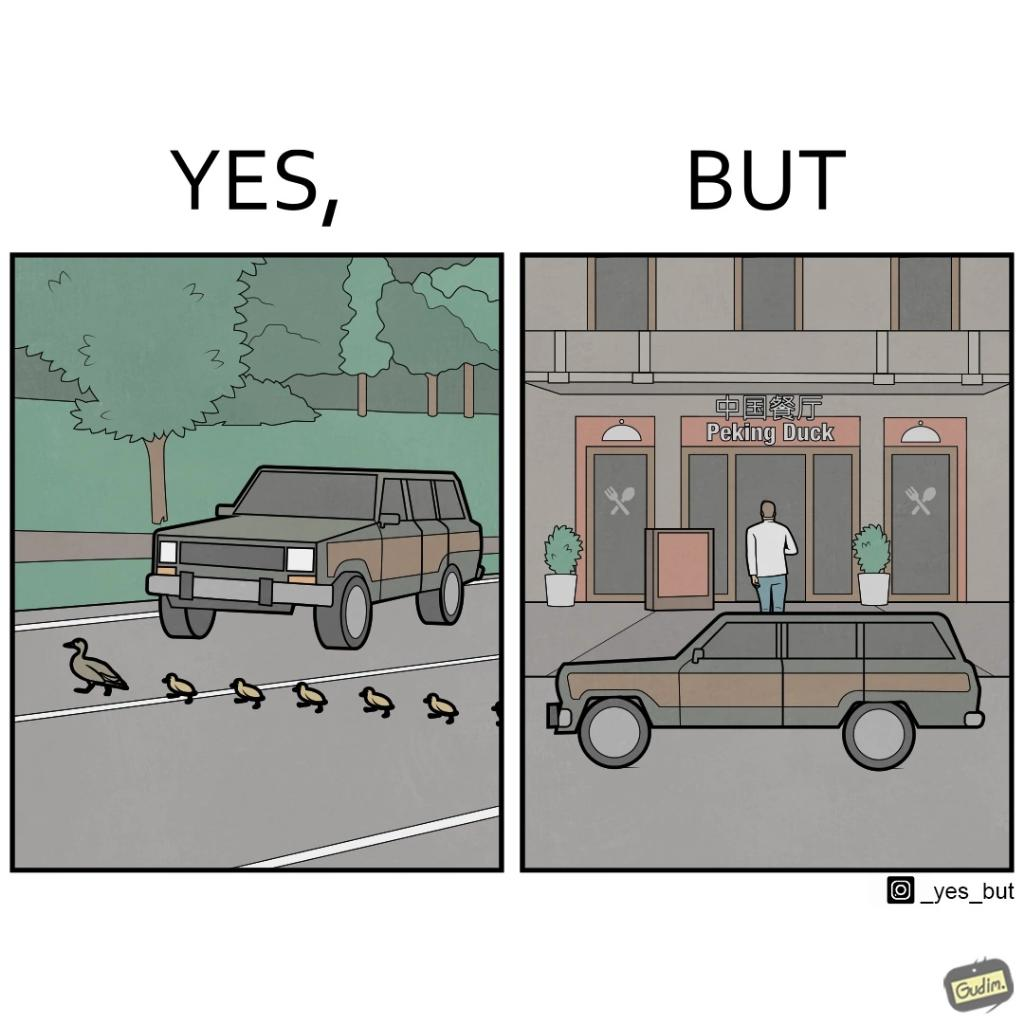Is this a satirical image? Yes, this image is satirical. 